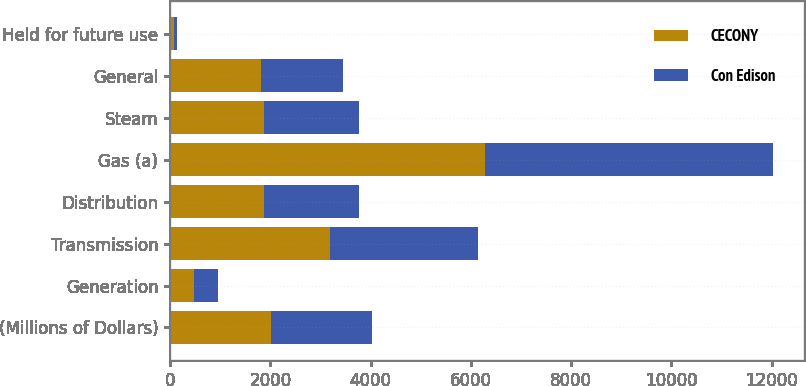<chart> <loc_0><loc_0><loc_500><loc_500><stacked_bar_chart><ecel><fcel>(Millions of Dollars)<fcel>Generation<fcel>Transmission<fcel>Distribution<fcel>Gas (a)<fcel>Steam<fcel>General<fcel>Held for future use<nl><fcel>CECONY<fcel>2016<fcel>479<fcel>3184<fcel>1882<fcel>6285<fcel>1882<fcel>1816<fcel>74<nl><fcel>Con Edison<fcel>2016<fcel>479<fcel>2963<fcel>1882<fcel>5749<fcel>1882<fcel>1639<fcel>65<nl></chart> 